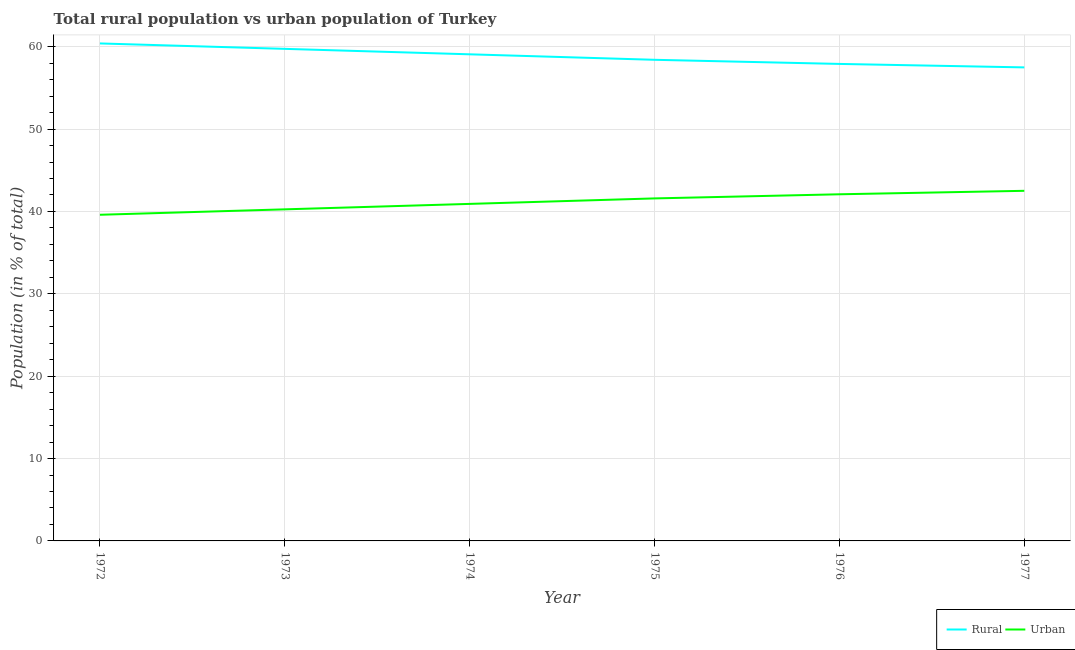How many different coloured lines are there?
Your response must be concise. 2. Does the line corresponding to rural population intersect with the line corresponding to urban population?
Give a very brief answer. No. What is the rural population in 1974?
Your response must be concise. 59.08. Across all years, what is the maximum rural population?
Your answer should be very brief. 60.4. Across all years, what is the minimum urban population?
Provide a short and direct response. 39.6. In which year was the urban population maximum?
Offer a terse response. 1977. In which year was the rural population minimum?
Keep it short and to the point. 1977. What is the total urban population in the graph?
Offer a very short reply. 246.96. What is the difference between the rural population in 1974 and that in 1975?
Your response must be concise. 0.67. What is the difference between the urban population in 1974 and the rural population in 1975?
Provide a succinct answer. -17.49. What is the average urban population per year?
Keep it short and to the point. 41.16. In the year 1974, what is the difference between the urban population and rural population?
Provide a succinct answer. -18.16. What is the ratio of the rural population in 1973 to that in 1976?
Give a very brief answer. 1.03. Is the difference between the urban population in 1973 and 1977 greater than the difference between the rural population in 1973 and 1977?
Give a very brief answer. No. What is the difference between the highest and the second highest urban population?
Make the answer very short. 0.42. What is the difference between the highest and the lowest rural population?
Offer a very short reply. 2.91. In how many years, is the rural population greater than the average rural population taken over all years?
Offer a terse response. 3. Is the sum of the rural population in 1975 and 1977 greater than the maximum urban population across all years?
Give a very brief answer. Yes. Does the rural population monotonically increase over the years?
Give a very brief answer. No. Is the rural population strictly less than the urban population over the years?
Your response must be concise. No. Are the values on the major ticks of Y-axis written in scientific E-notation?
Your answer should be very brief. No. How are the legend labels stacked?
Make the answer very short. Horizontal. What is the title of the graph?
Make the answer very short. Total rural population vs urban population of Turkey. Does "Under five" appear as one of the legend labels in the graph?
Offer a very short reply. No. What is the label or title of the X-axis?
Offer a terse response. Year. What is the label or title of the Y-axis?
Make the answer very short. Population (in % of total). What is the Population (in % of total) of Rural in 1972?
Make the answer very short. 60.4. What is the Population (in % of total) in Urban in 1972?
Make the answer very short. 39.6. What is the Population (in % of total) in Rural in 1973?
Provide a short and direct response. 59.74. What is the Population (in % of total) in Urban in 1973?
Provide a succinct answer. 40.26. What is the Population (in % of total) of Rural in 1974?
Offer a terse response. 59.08. What is the Population (in % of total) in Urban in 1974?
Make the answer very short. 40.92. What is the Population (in % of total) in Rural in 1975?
Ensure brevity in your answer.  58.41. What is the Population (in % of total) of Urban in 1975?
Provide a succinct answer. 41.59. What is the Population (in % of total) in Rural in 1976?
Offer a terse response. 57.91. What is the Population (in % of total) in Urban in 1976?
Offer a terse response. 42.09. What is the Population (in % of total) in Rural in 1977?
Your answer should be compact. 57.49. What is the Population (in % of total) in Urban in 1977?
Give a very brief answer. 42.51. Across all years, what is the maximum Population (in % of total) of Rural?
Make the answer very short. 60.4. Across all years, what is the maximum Population (in % of total) in Urban?
Provide a succinct answer. 42.51. Across all years, what is the minimum Population (in % of total) in Rural?
Your answer should be very brief. 57.49. Across all years, what is the minimum Population (in % of total) of Urban?
Offer a very short reply. 39.6. What is the total Population (in % of total) of Rural in the graph?
Ensure brevity in your answer.  353.04. What is the total Population (in % of total) of Urban in the graph?
Offer a terse response. 246.96. What is the difference between the Population (in % of total) of Rural in 1972 and that in 1973?
Keep it short and to the point. 0.66. What is the difference between the Population (in % of total) of Urban in 1972 and that in 1973?
Provide a succinct answer. -0.66. What is the difference between the Population (in % of total) in Rural in 1972 and that in 1974?
Your response must be concise. 1.32. What is the difference between the Population (in % of total) of Urban in 1972 and that in 1974?
Your answer should be compact. -1.32. What is the difference between the Population (in % of total) of Rural in 1972 and that in 1975?
Ensure brevity in your answer.  1.99. What is the difference between the Population (in % of total) of Urban in 1972 and that in 1975?
Provide a short and direct response. -1.99. What is the difference between the Population (in % of total) in Rural in 1972 and that in 1976?
Provide a succinct answer. 2.49. What is the difference between the Population (in % of total) of Urban in 1972 and that in 1976?
Your answer should be compact. -2.49. What is the difference between the Population (in % of total) in Rural in 1972 and that in 1977?
Ensure brevity in your answer.  2.91. What is the difference between the Population (in % of total) of Urban in 1972 and that in 1977?
Provide a succinct answer. -2.91. What is the difference between the Population (in % of total) in Rural in 1973 and that in 1974?
Ensure brevity in your answer.  0.66. What is the difference between the Population (in % of total) of Urban in 1973 and that in 1974?
Ensure brevity in your answer.  -0.66. What is the difference between the Population (in % of total) of Rural in 1973 and that in 1975?
Provide a short and direct response. 1.33. What is the difference between the Population (in % of total) of Urban in 1973 and that in 1975?
Offer a very short reply. -1.33. What is the difference between the Population (in % of total) of Rural in 1973 and that in 1976?
Give a very brief answer. 1.83. What is the difference between the Population (in % of total) of Urban in 1973 and that in 1976?
Provide a succinct answer. -1.83. What is the difference between the Population (in % of total) of Rural in 1973 and that in 1977?
Your answer should be compact. 2.25. What is the difference between the Population (in % of total) of Urban in 1973 and that in 1977?
Provide a short and direct response. -2.25. What is the difference between the Population (in % of total) of Rural in 1974 and that in 1975?
Your answer should be very brief. 0.67. What is the difference between the Population (in % of total) in Urban in 1974 and that in 1975?
Provide a succinct answer. -0.67. What is the difference between the Population (in % of total) of Rural in 1974 and that in 1976?
Your response must be concise. 1.17. What is the difference between the Population (in % of total) of Urban in 1974 and that in 1976?
Your answer should be compact. -1.17. What is the difference between the Population (in % of total) in Rural in 1974 and that in 1977?
Your answer should be very brief. 1.59. What is the difference between the Population (in % of total) of Urban in 1974 and that in 1977?
Offer a very short reply. -1.59. What is the difference between the Population (in % of total) of Rural in 1975 and that in 1976?
Offer a terse response. 0.5. What is the difference between the Population (in % of total) of Urban in 1975 and that in 1976?
Offer a very short reply. -0.5. What is the difference between the Population (in % of total) of Rural in 1975 and that in 1977?
Give a very brief answer. 0.92. What is the difference between the Population (in % of total) in Urban in 1975 and that in 1977?
Offer a very short reply. -0.92. What is the difference between the Population (in % of total) in Rural in 1976 and that in 1977?
Offer a very short reply. 0.42. What is the difference between the Population (in % of total) in Urban in 1976 and that in 1977?
Your answer should be compact. -0.42. What is the difference between the Population (in % of total) in Rural in 1972 and the Population (in % of total) in Urban in 1973?
Keep it short and to the point. 20.14. What is the difference between the Population (in % of total) of Rural in 1972 and the Population (in % of total) of Urban in 1974?
Your response must be concise. 19.48. What is the difference between the Population (in % of total) in Rural in 1972 and the Population (in % of total) in Urban in 1975?
Your response must be concise. 18.81. What is the difference between the Population (in % of total) of Rural in 1972 and the Population (in % of total) of Urban in 1976?
Offer a very short reply. 18.31. What is the difference between the Population (in % of total) in Rural in 1972 and the Population (in % of total) in Urban in 1977?
Ensure brevity in your answer.  17.89. What is the difference between the Population (in % of total) in Rural in 1973 and the Population (in % of total) in Urban in 1974?
Provide a succinct answer. 18.82. What is the difference between the Population (in % of total) of Rural in 1973 and the Population (in % of total) of Urban in 1975?
Keep it short and to the point. 18.16. What is the difference between the Population (in % of total) in Rural in 1973 and the Population (in % of total) in Urban in 1976?
Your answer should be very brief. 17.66. What is the difference between the Population (in % of total) in Rural in 1973 and the Population (in % of total) in Urban in 1977?
Provide a succinct answer. 17.23. What is the difference between the Population (in % of total) in Rural in 1974 and the Population (in % of total) in Urban in 1975?
Give a very brief answer. 17.49. What is the difference between the Population (in % of total) of Rural in 1974 and the Population (in % of total) of Urban in 1976?
Offer a very short reply. 16.99. What is the difference between the Population (in % of total) in Rural in 1974 and the Population (in % of total) in Urban in 1977?
Your answer should be compact. 16.57. What is the difference between the Population (in % of total) in Rural in 1975 and the Population (in % of total) in Urban in 1976?
Offer a very short reply. 16.33. What is the difference between the Population (in % of total) of Rural in 1975 and the Population (in % of total) of Urban in 1977?
Offer a very short reply. 15.91. What is the difference between the Population (in % of total) of Rural in 1976 and the Population (in % of total) of Urban in 1977?
Offer a very short reply. 15.4. What is the average Population (in % of total) of Rural per year?
Offer a very short reply. 58.84. What is the average Population (in % of total) in Urban per year?
Make the answer very short. 41.16. In the year 1972, what is the difference between the Population (in % of total) of Rural and Population (in % of total) of Urban?
Keep it short and to the point. 20.8. In the year 1973, what is the difference between the Population (in % of total) in Rural and Population (in % of total) in Urban?
Your answer should be very brief. 19.48. In the year 1974, what is the difference between the Population (in % of total) of Rural and Population (in % of total) of Urban?
Your answer should be very brief. 18.16. In the year 1975, what is the difference between the Population (in % of total) in Rural and Population (in % of total) in Urban?
Give a very brief answer. 16.83. In the year 1976, what is the difference between the Population (in % of total) in Rural and Population (in % of total) in Urban?
Provide a short and direct response. 15.83. In the year 1977, what is the difference between the Population (in % of total) in Rural and Population (in % of total) in Urban?
Your answer should be very brief. 14.98. What is the ratio of the Population (in % of total) in Urban in 1972 to that in 1973?
Provide a succinct answer. 0.98. What is the ratio of the Population (in % of total) of Rural in 1972 to that in 1974?
Provide a succinct answer. 1.02. What is the ratio of the Population (in % of total) in Rural in 1972 to that in 1975?
Your answer should be very brief. 1.03. What is the ratio of the Population (in % of total) in Urban in 1972 to that in 1975?
Ensure brevity in your answer.  0.95. What is the ratio of the Population (in % of total) in Rural in 1972 to that in 1976?
Ensure brevity in your answer.  1.04. What is the ratio of the Population (in % of total) of Urban in 1972 to that in 1976?
Ensure brevity in your answer.  0.94. What is the ratio of the Population (in % of total) in Rural in 1972 to that in 1977?
Make the answer very short. 1.05. What is the ratio of the Population (in % of total) in Urban in 1972 to that in 1977?
Offer a terse response. 0.93. What is the ratio of the Population (in % of total) in Rural in 1973 to that in 1974?
Make the answer very short. 1.01. What is the ratio of the Population (in % of total) of Urban in 1973 to that in 1974?
Your answer should be compact. 0.98. What is the ratio of the Population (in % of total) in Rural in 1973 to that in 1975?
Your answer should be very brief. 1.02. What is the ratio of the Population (in % of total) in Urban in 1973 to that in 1975?
Your response must be concise. 0.97. What is the ratio of the Population (in % of total) in Rural in 1973 to that in 1976?
Provide a short and direct response. 1.03. What is the ratio of the Population (in % of total) in Urban in 1973 to that in 1976?
Your answer should be very brief. 0.96. What is the ratio of the Population (in % of total) in Rural in 1973 to that in 1977?
Your answer should be very brief. 1.04. What is the ratio of the Population (in % of total) in Urban in 1973 to that in 1977?
Your answer should be compact. 0.95. What is the ratio of the Population (in % of total) of Rural in 1974 to that in 1975?
Your answer should be very brief. 1.01. What is the ratio of the Population (in % of total) in Urban in 1974 to that in 1975?
Provide a succinct answer. 0.98. What is the ratio of the Population (in % of total) in Rural in 1974 to that in 1976?
Your response must be concise. 1.02. What is the ratio of the Population (in % of total) of Urban in 1974 to that in 1976?
Ensure brevity in your answer.  0.97. What is the ratio of the Population (in % of total) of Rural in 1974 to that in 1977?
Your answer should be very brief. 1.03. What is the ratio of the Population (in % of total) of Urban in 1974 to that in 1977?
Provide a short and direct response. 0.96. What is the ratio of the Population (in % of total) of Rural in 1975 to that in 1976?
Provide a short and direct response. 1.01. What is the ratio of the Population (in % of total) in Urban in 1975 to that in 1977?
Make the answer very short. 0.98. What is the ratio of the Population (in % of total) of Rural in 1976 to that in 1977?
Provide a short and direct response. 1.01. What is the ratio of the Population (in % of total) of Urban in 1976 to that in 1977?
Your answer should be very brief. 0.99. What is the difference between the highest and the second highest Population (in % of total) in Rural?
Make the answer very short. 0.66. What is the difference between the highest and the second highest Population (in % of total) of Urban?
Provide a succinct answer. 0.42. What is the difference between the highest and the lowest Population (in % of total) of Rural?
Provide a succinct answer. 2.91. What is the difference between the highest and the lowest Population (in % of total) in Urban?
Provide a short and direct response. 2.91. 